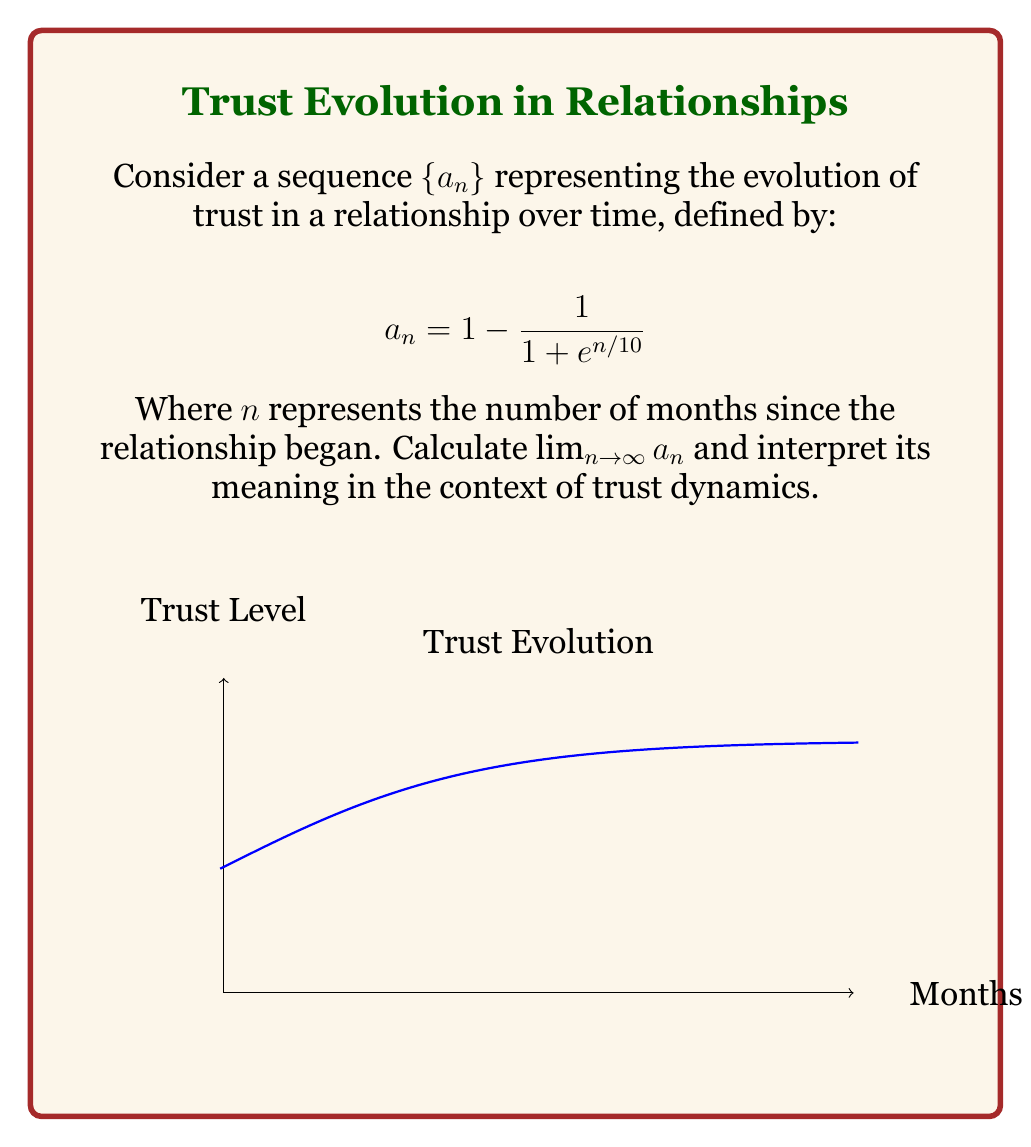Show me your answer to this math problem. To solve this problem, we'll follow these steps:

1) First, let's examine the general form of the sequence:
   $$a_n = 1 - \frac{1}{1 + e^{n/10}}$$

2) To find the limit as $n$ approaches infinity, we need to consider what happens to $e^{n/10}$ as $n$ grows very large:
   $$\lim_{n \to \infty} e^{n/10} = \infty$$

3) This means that as $n$ approaches infinity, $1 + e^{n/10}$ also approaches infinity.

4) Now, let's look at the fraction part of our sequence:
   $$\lim_{n \to \infty} \frac{1}{1 + e^{n/10}} = \frac{1}{\infty} = 0$$

5) Therefore, our limit becomes:
   $$\lim_{n \to \infty} a_n = \lim_{n \to \infty} (1 - \frac{1}{1 + e^{n/10}}) = 1 - 0 = 1$$

6) Interpretation: In the context of trust dynamics, this limit suggests that as time (measured in months) goes to infinity, the trust level approaches 1, or 100%. This models a relationship where trust gradually builds over time, asymptotically approaching complete trust.
Answer: $\lim_{n \to \infty} a_n = 1$ 